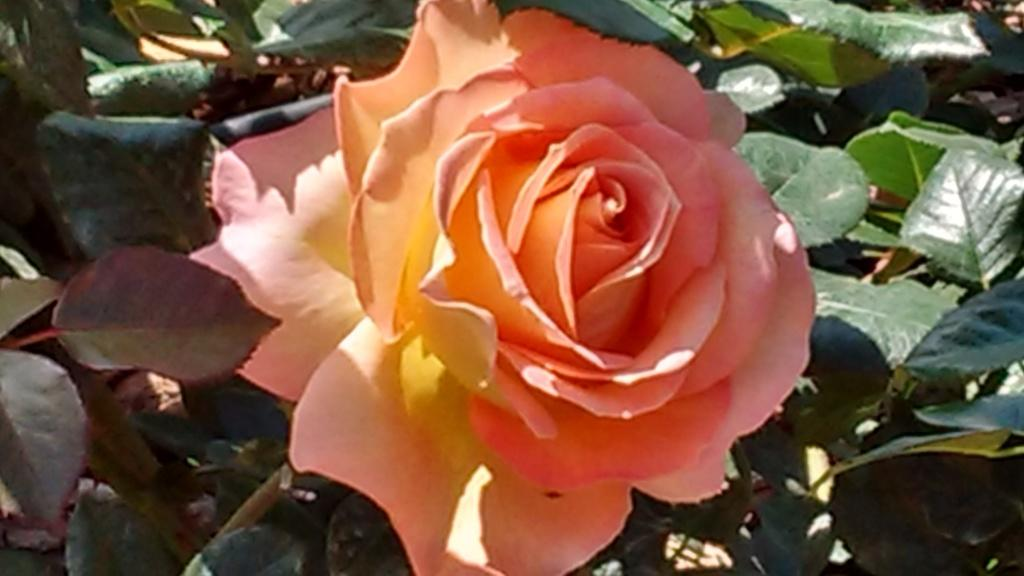What type of plant life can be seen in the image? There are flowers and leaves in the image. Can you describe the flowers in the image? Unfortunately, the facts provided do not give specific details about the flowers. What is the context or setting of the image? The facts provided do not give information about the context or setting of the image. What type of shoes can be seen in the image? There are no shoes present in the image; it only features flowers and leaves. What rhythm is being played in the background of the image? There is no mention of music or rhythm in the image, as it only contains flowers and leaves. 